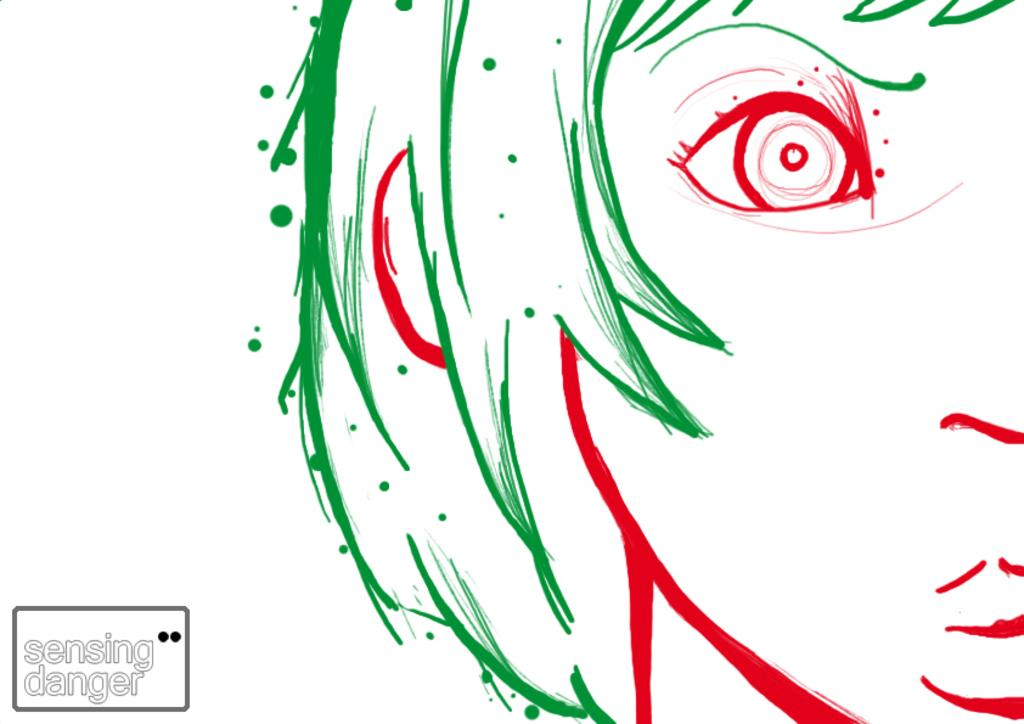What is the main subject of the image? There is a sketch of a person's face in the image. What color is the background of the image? The background of the image is white. Is there any text present in the image? Yes, there is some text at the bottom left of the image. What type of eggnog is being served in the middle of the image? There is no eggnog present in the image; it features a sketch of a person's face with a white background and some text at the bottom left. What symbol of peace can be seen in the image? There is no symbol of peace depicted in the image; it only contains a sketch of a person's face, a white background, and some text at the bottom left. 